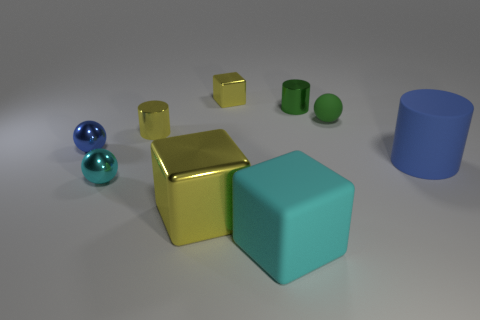Subtract all cubes. How many objects are left? 6 Add 1 tiny green cylinders. How many tiny green cylinders exist? 2 Subtract 1 blue spheres. How many objects are left? 8 Subtract all tiny cyan blocks. Subtract all small yellow metallic cylinders. How many objects are left? 8 Add 1 large blue rubber objects. How many large blue rubber objects are left? 2 